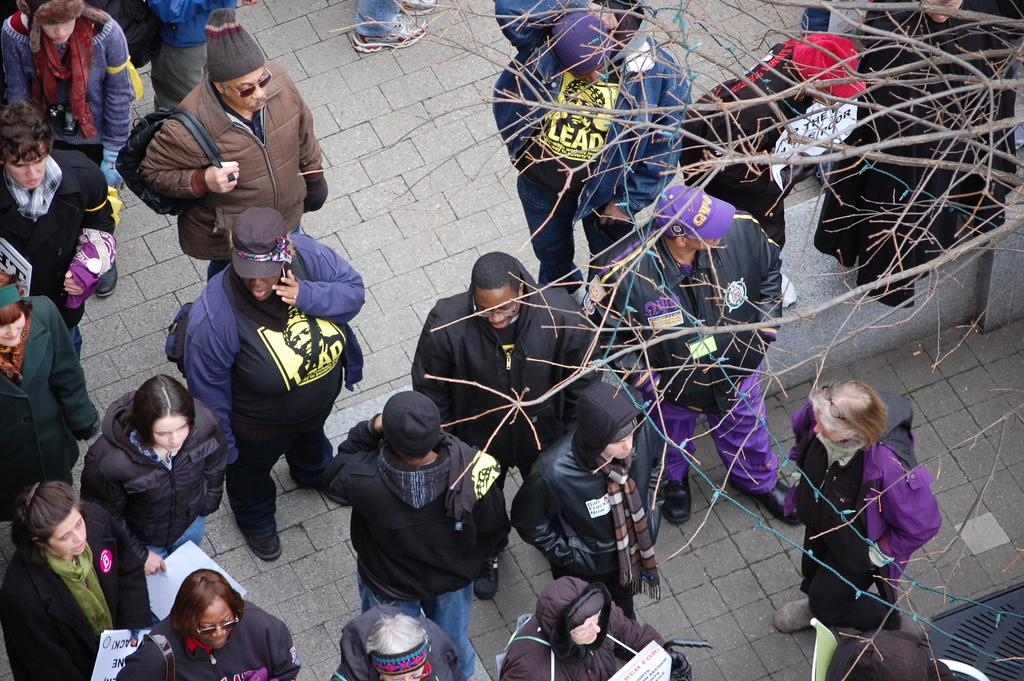How many people are in the image? There is a group of people standing in the image, but the exact number cannot be determined from the provided facts. What can be seen in the background of the image? There is a tree in the image. What type of care is being provided to the town in the image? There is no town or indication of care being provided in the image; it only shows a group of people and a tree. 